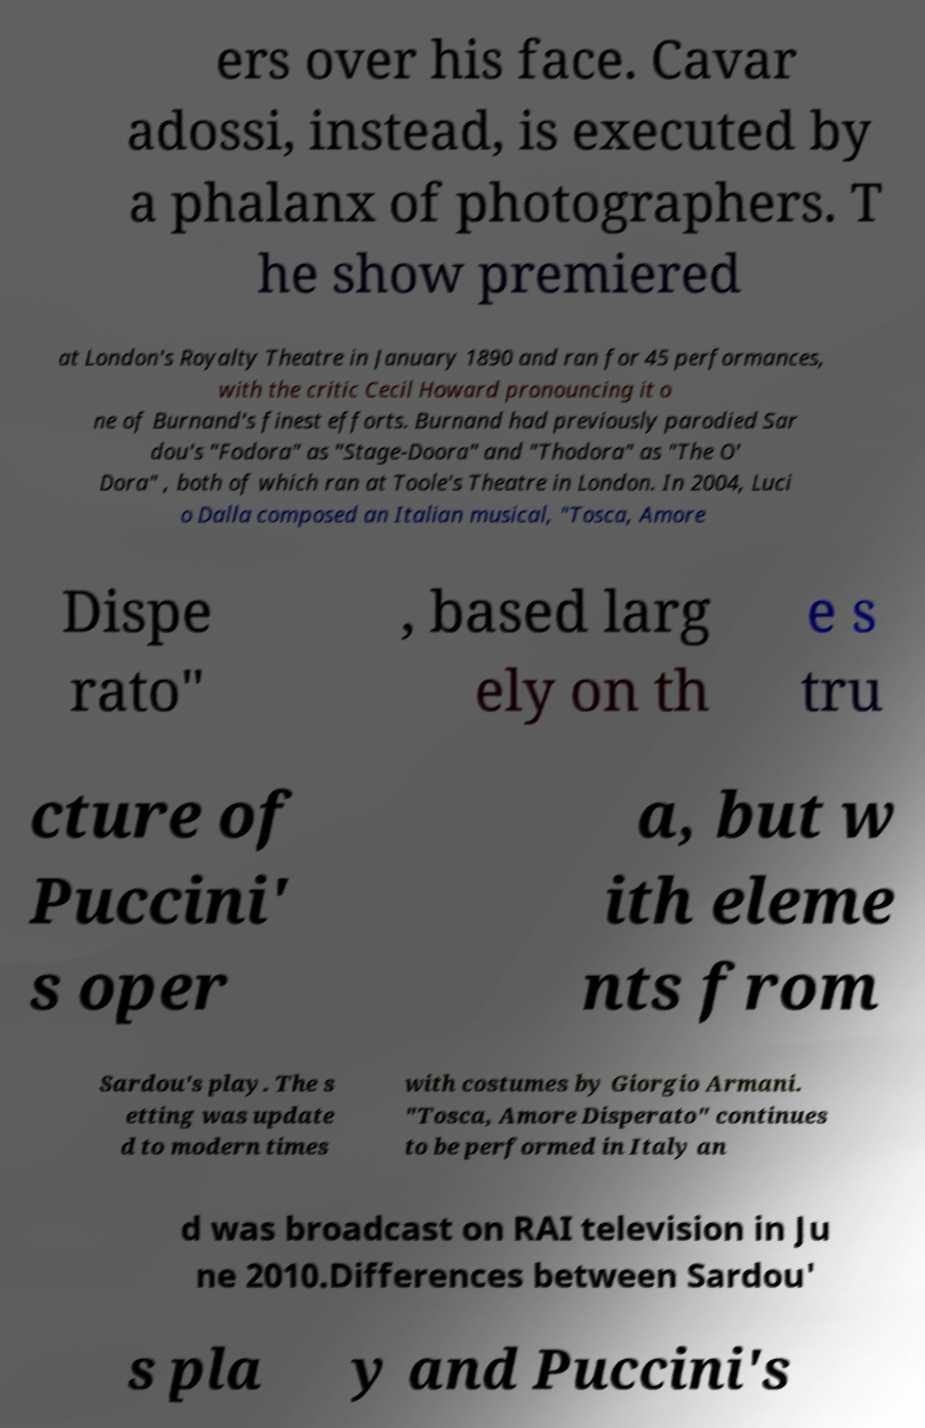What messages or text are displayed in this image? I need them in a readable, typed format. ers over his face. Cavar adossi, instead, is executed by a phalanx of photographers. T he show premiered at London's Royalty Theatre in January 1890 and ran for 45 performances, with the critic Cecil Howard pronouncing it o ne of Burnand's finest efforts. Burnand had previously parodied Sar dou's "Fodora" as "Stage-Doora" and "Thodora" as "The O' Dora" , both of which ran at Toole's Theatre in London. In 2004, Luci o Dalla composed an Italian musical, "Tosca, Amore Dispe rato" , based larg ely on th e s tru cture of Puccini' s oper a, but w ith eleme nts from Sardou's play. The s etting was update d to modern times with costumes by Giorgio Armani. "Tosca, Amore Disperato" continues to be performed in Italy an d was broadcast on RAI television in Ju ne 2010.Differences between Sardou' s pla y and Puccini's 